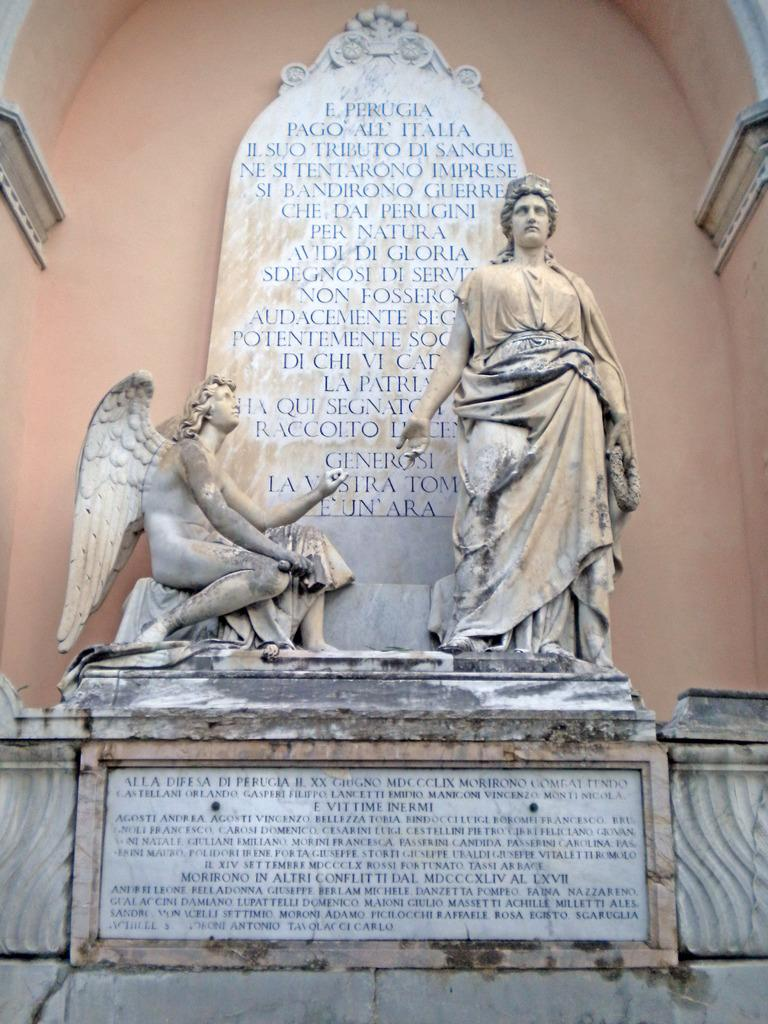What can be seen in the image that resembles art? There are two sculptures in the image. What other objects are present in the image? There are two stone boards in the image. Can you describe the text or symbols on the stone boards? There is writing on the stone boards. What type of produce can be seen growing on the mountain in the image? There is no mountain or produce present in the image. What type of twig is being used as a prop in the image? There is no twig being used as a prop in the image. 